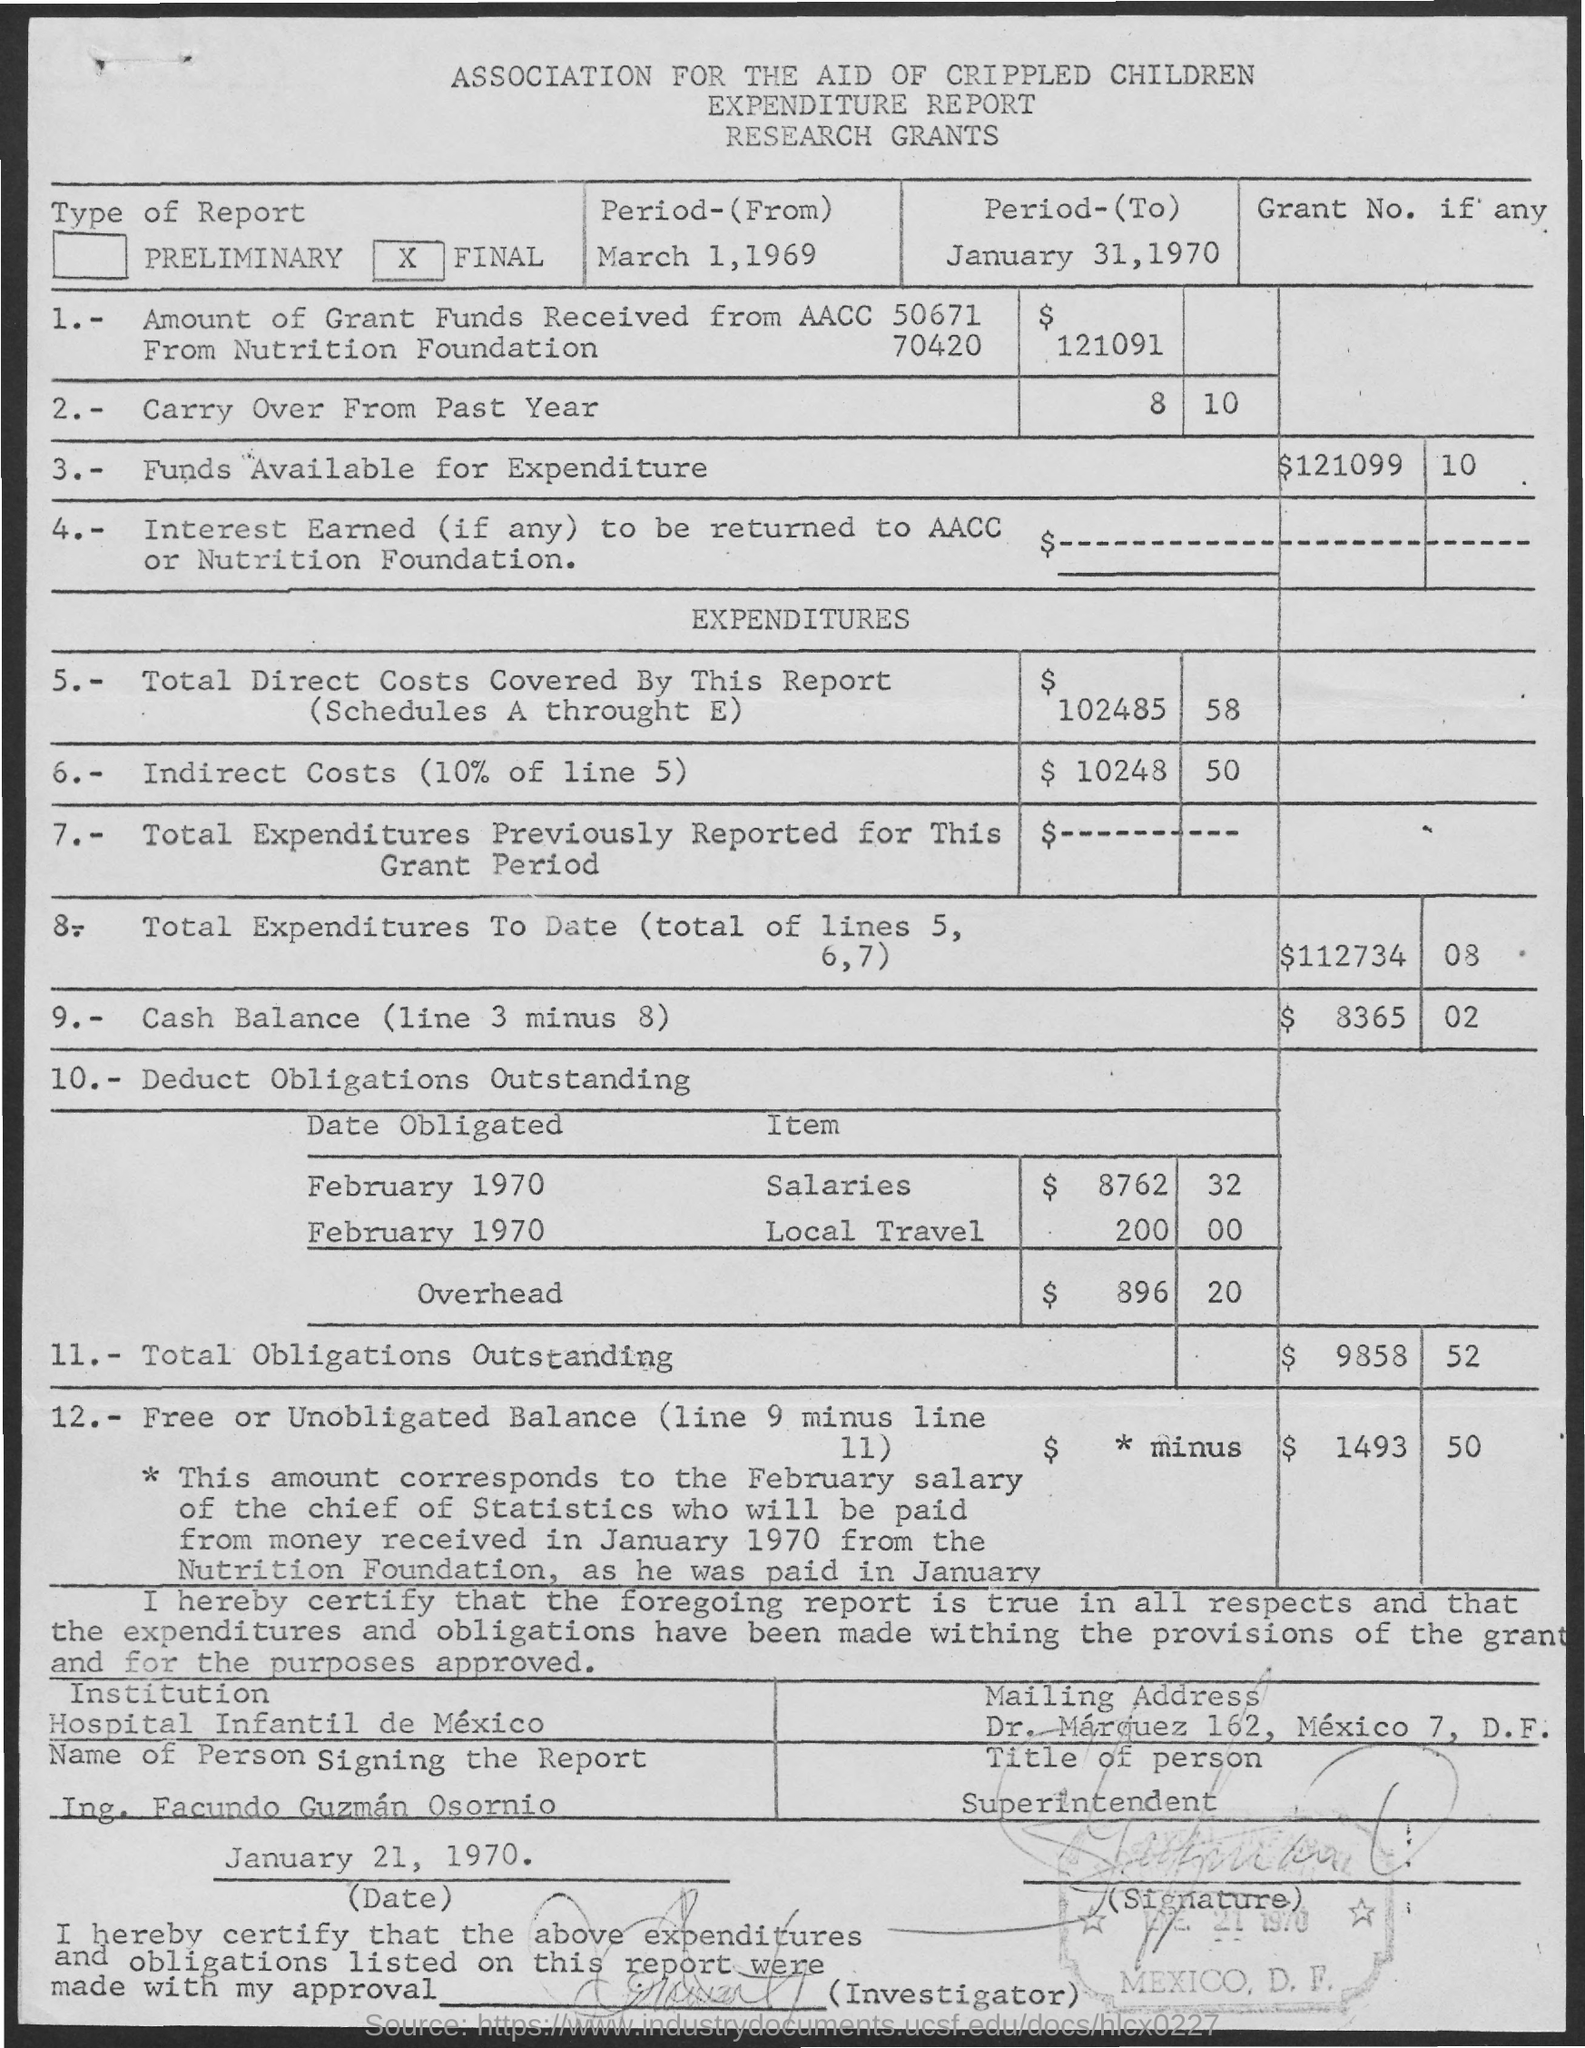Highlight a few significant elements in this photo. The institution is the Hospital Infantil de Mexico. The total direct costs covered by this report are 102,485.58. The title of the person is Superintendent. The indirect costs total $10,248.50. What funds are available for expenditure total $121099? 